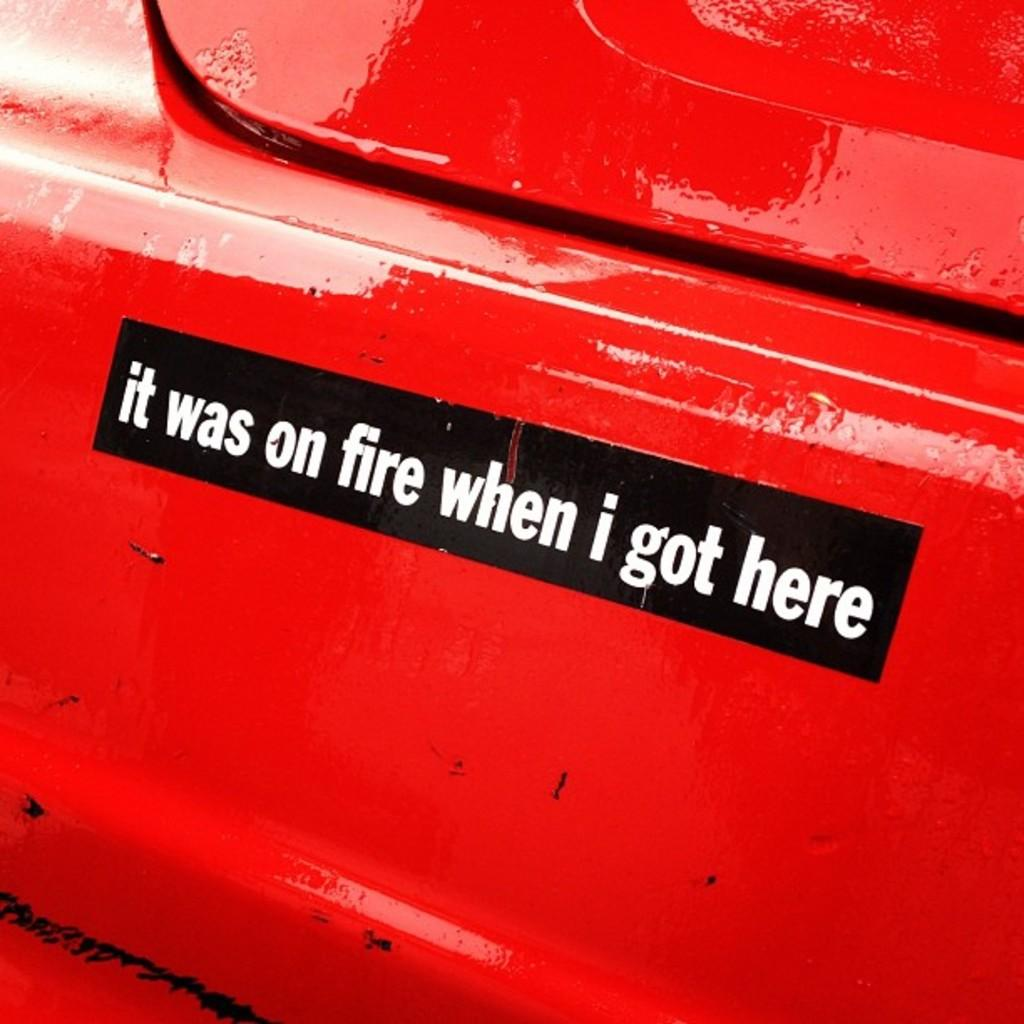What is the main subject of the image? The main subject of the image is the backside of a car. Can you describe any specific features or details on the car? Yes, there is writing on the car. What color is the hair of the person driving the car in the image? There is no person or hair visible in the image; it only shows the backside of a car with writing on it. 